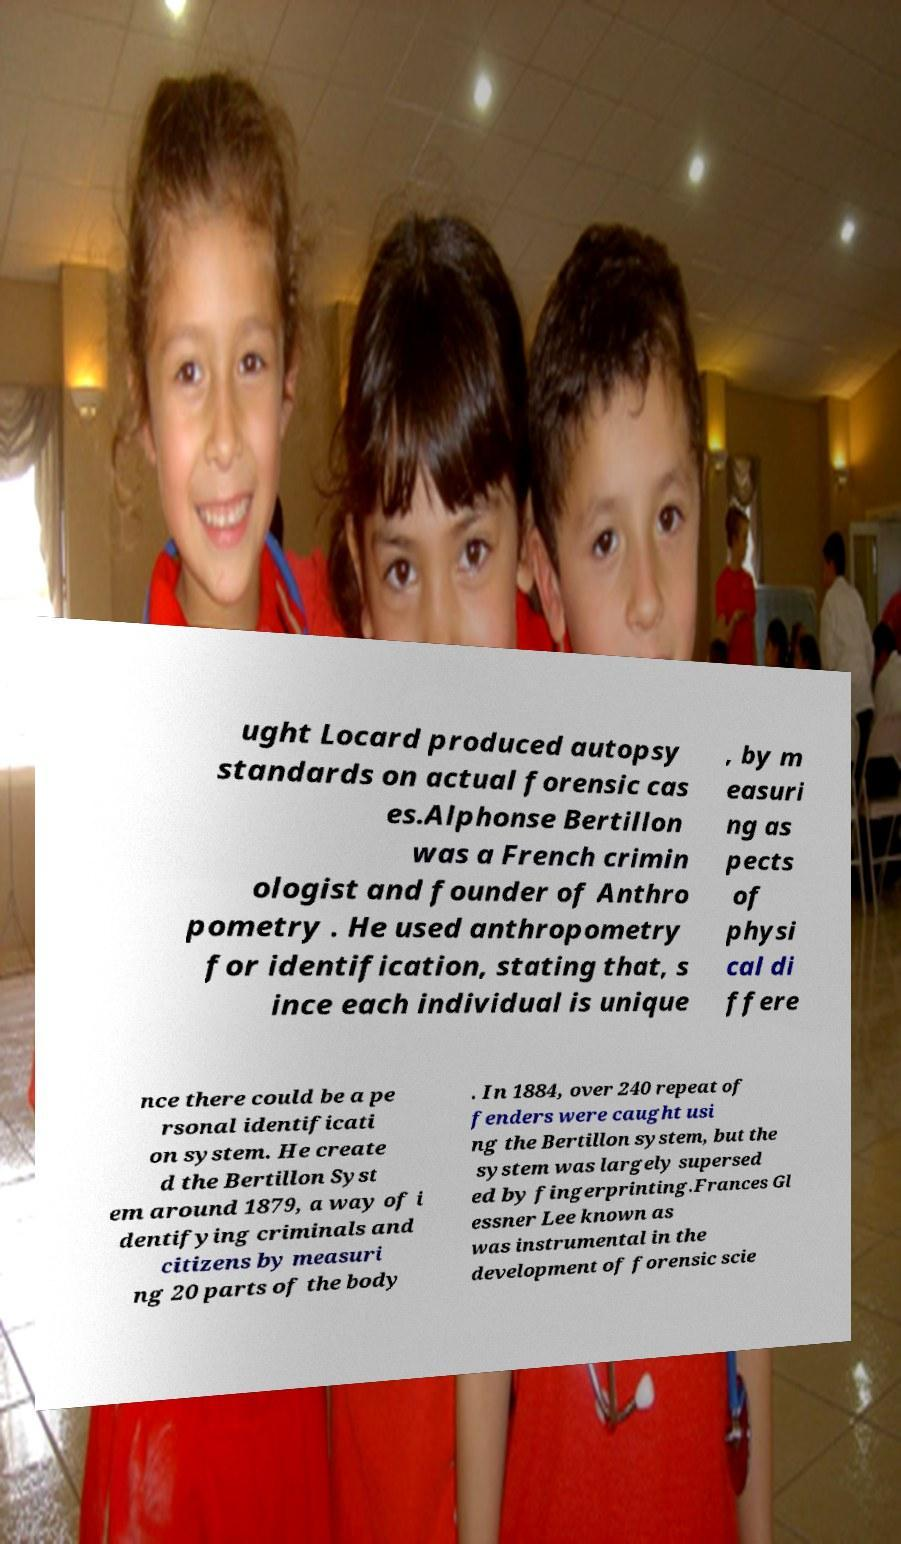For documentation purposes, I need the text within this image transcribed. Could you provide that? ught Locard produced autopsy standards on actual forensic cas es.Alphonse Bertillon was a French crimin ologist and founder of Anthro pometry . He used anthropometry for identification, stating that, s ince each individual is unique , by m easuri ng as pects of physi cal di ffere nce there could be a pe rsonal identificati on system. He create d the Bertillon Syst em around 1879, a way of i dentifying criminals and citizens by measuri ng 20 parts of the body . In 1884, over 240 repeat of fenders were caught usi ng the Bertillon system, but the system was largely supersed ed by fingerprinting.Frances Gl essner Lee known as was instrumental in the development of forensic scie 